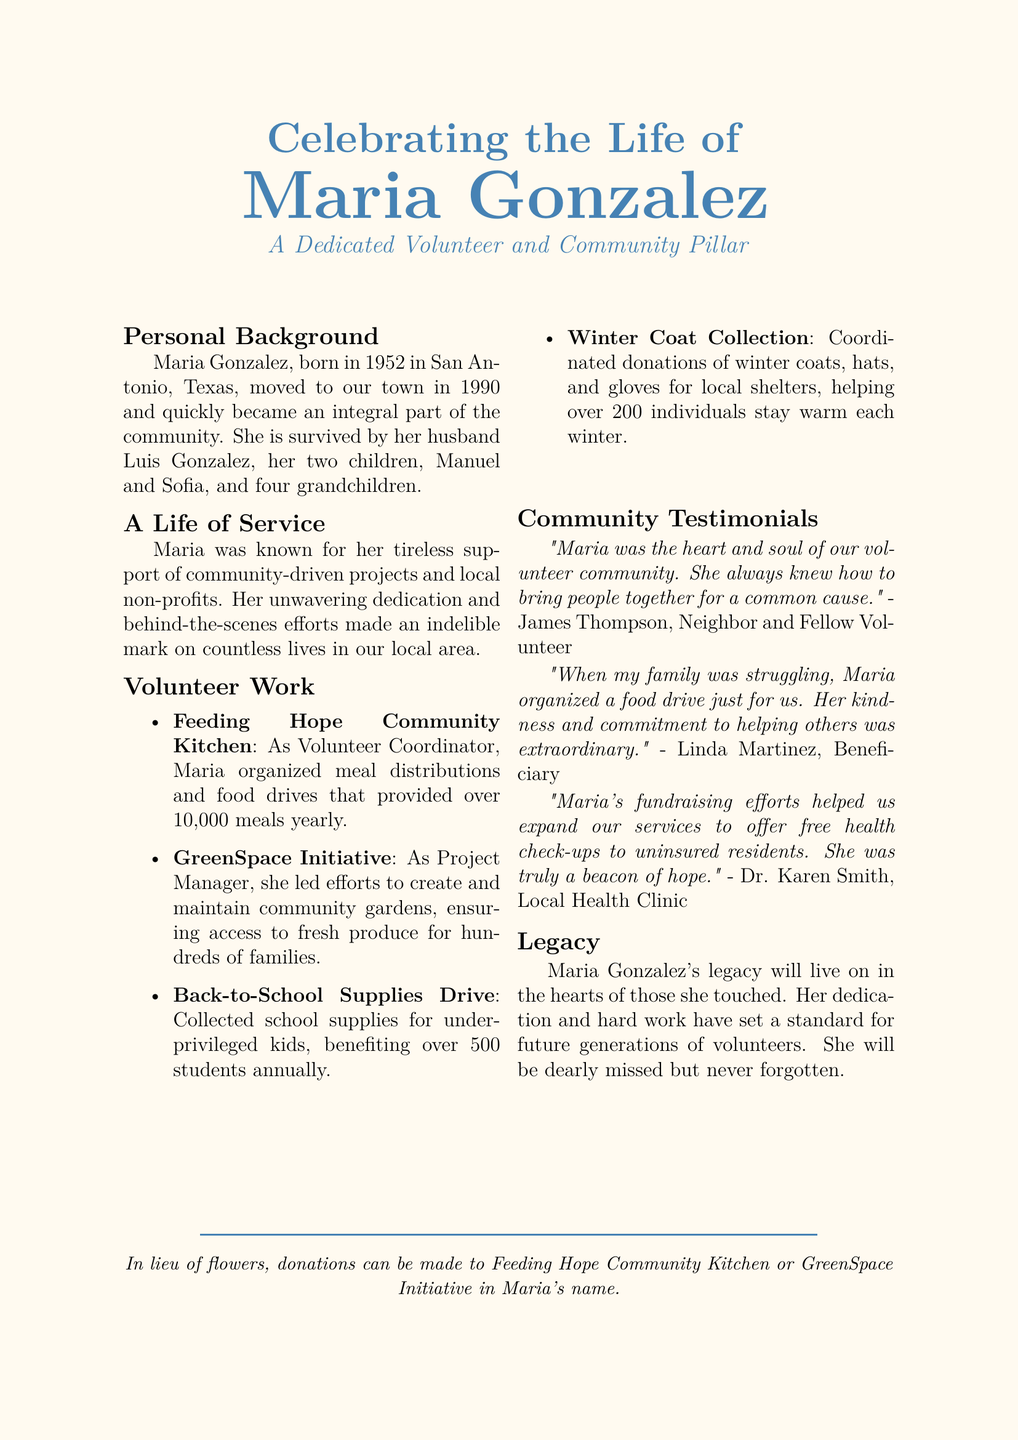What year was Maria Gonzalez born? The document states that Maria Gonzalez was born in 1952.
Answer: 1952 Who is Maria Gonzalez survived by? The obituary lists her husband, children, and grandchildren, indicating her survivors.
Answer: Luis, Manuel, Sofia, four grandchildren What was Maria's role at Feeding Hope Community Kitchen? The document specifies her title and responsibilities at the organization, highlighting her contributions.
Answer: Volunteer Coordinator How many meals did she help provide yearly? The document states, under her efforts, that over 10,000 meals were provided annually.
Answer: over 10,000 meals How many students benefited from the Back-to-School Supplies Drive? The document provides a specific number of students who received assistance from this initiative.
Answer: over 500 students What did Linda Martinez say about Maria? The testimonial reflects personal impact and gratitude from a beneficiary regarding Maria's actions.
Answer: "When my family was struggling, Maria organized a food drive just for us." What type of projects did Maria work on? The obituary describes various community-driven projects and local non-profits she supported.
Answer: Community-driven projects What does Maria's legacy symbolize? The document concludes by summarizing her contributions and influence on future generations.
Answer: A standard for future generations of volunteers 